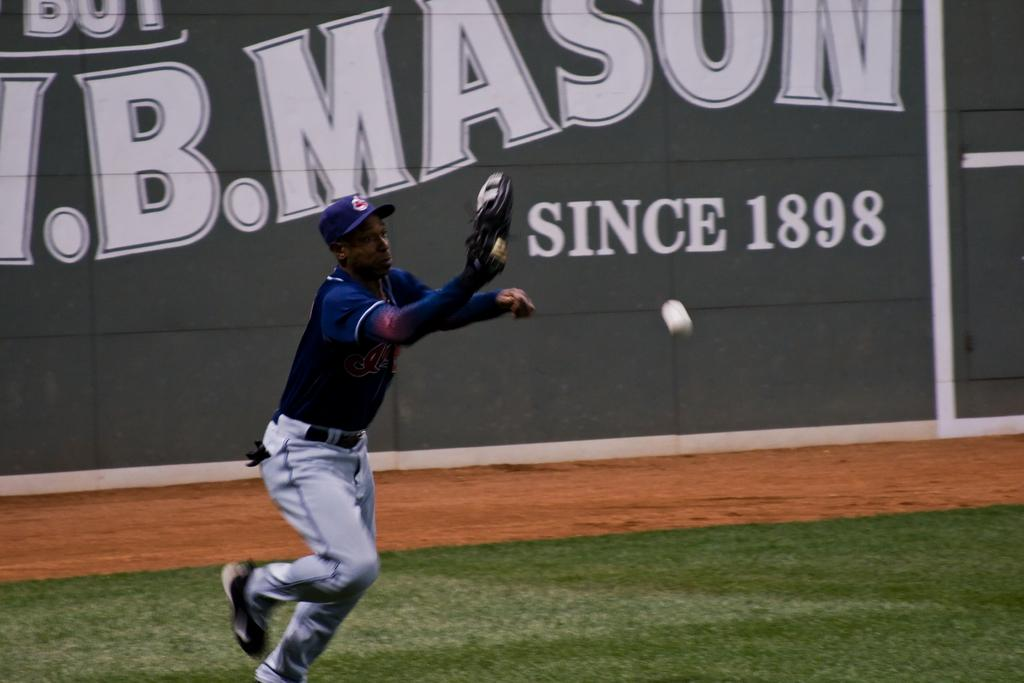Provide a one-sentence caption for the provided image. a man throwing a ball with a sign reading 'since 1898' behind him. 